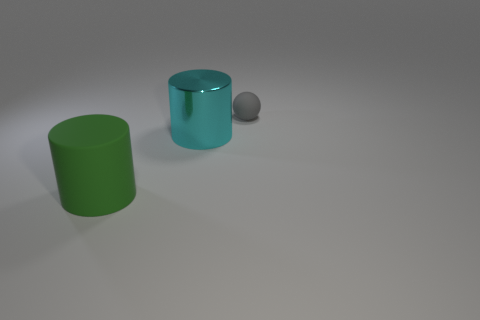Add 2 big cyan cylinders. How many objects exist? 5 Subtract all balls. How many objects are left? 2 Subtract all rubber cylinders. Subtract all large green objects. How many objects are left? 1 Add 1 green rubber cylinders. How many green rubber cylinders are left? 2 Add 3 large cyan metal cylinders. How many large cyan metal cylinders exist? 4 Subtract 0 purple balls. How many objects are left? 3 